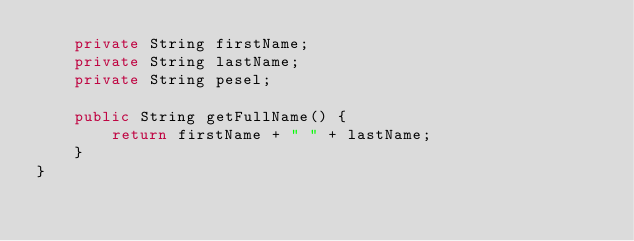Convert code to text. <code><loc_0><loc_0><loc_500><loc_500><_Java_>    private String firstName;
    private String lastName;
    private String pesel;

    public String getFullName() {
        return firstName + " " + lastName;
    }
}
</code> 